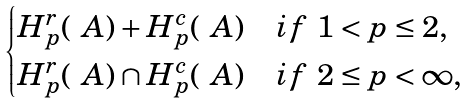Convert formula to latex. <formula><loc_0><loc_0><loc_500><loc_500>\begin{cases} H _ { p } ^ { r } ( \ A ) + H _ { p } ^ { c } ( \ A ) & i f \ 1 < p \leq 2 , \\ H _ { p } ^ { r } ( \ A ) \cap H _ { p } ^ { c } ( \ A ) & i f \ 2 \leq p < \infty , \end{cases}</formula> 